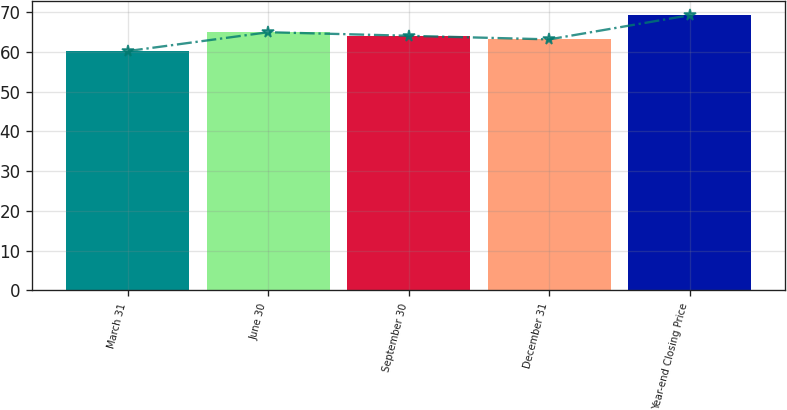Convert chart. <chart><loc_0><loc_0><loc_500><loc_500><bar_chart><fcel>March 31<fcel>June 30<fcel>September 30<fcel>December 31<fcel>Year-end Closing Price<nl><fcel>60.17<fcel>64.91<fcel>64.01<fcel>63.11<fcel>69.19<nl></chart> 